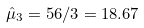<formula> <loc_0><loc_0><loc_500><loc_500>\hat { \mu } _ { 3 } = 5 6 / 3 = 1 8 . 6 7</formula> 